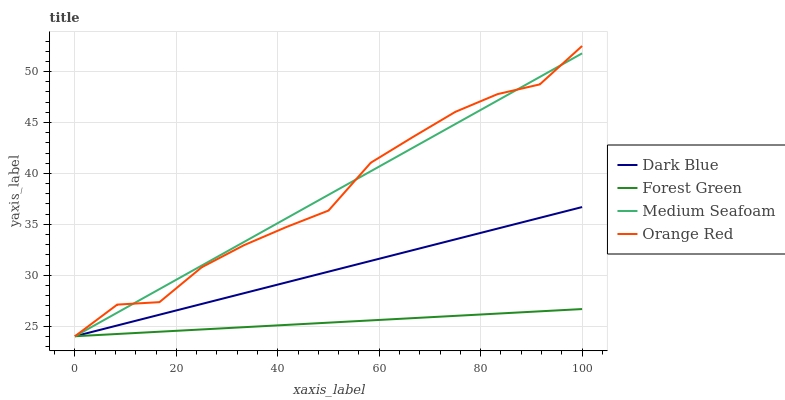Does Forest Green have the minimum area under the curve?
Answer yes or no. Yes. Does Medium Seafoam have the maximum area under the curve?
Answer yes or no. Yes. Does Medium Seafoam have the minimum area under the curve?
Answer yes or no. No. Does Forest Green have the maximum area under the curve?
Answer yes or no. No. Is Dark Blue the smoothest?
Answer yes or no. Yes. Is Orange Red the roughest?
Answer yes or no. Yes. Is Forest Green the smoothest?
Answer yes or no. No. Is Forest Green the roughest?
Answer yes or no. No. Does Dark Blue have the lowest value?
Answer yes or no. Yes. Does Orange Red have the highest value?
Answer yes or no. Yes. Does Medium Seafoam have the highest value?
Answer yes or no. No. Does Dark Blue intersect Medium Seafoam?
Answer yes or no. Yes. Is Dark Blue less than Medium Seafoam?
Answer yes or no. No. Is Dark Blue greater than Medium Seafoam?
Answer yes or no. No. 